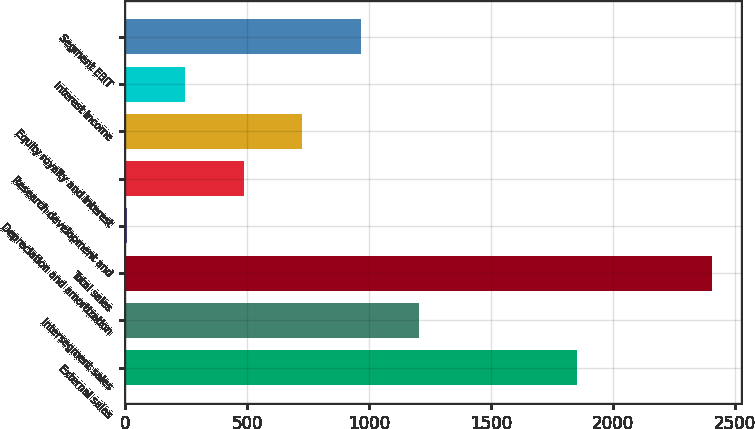Convert chart. <chart><loc_0><loc_0><loc_500><loc_500><bar_chart><fcel>External sales<fcel>Intersegment sales<fcel>Total sales<fcel>Depreciation and amortization<fcel>Research development and<fcel>Equity royalty and interest<fcel>Interest income<fcel>Segment EBIT<nl><fcel>1850<fcel>1205<fcel>2405<fcel>5<fcel>485<fcel>725<fcel>245<fcel>965<nl></chart> 